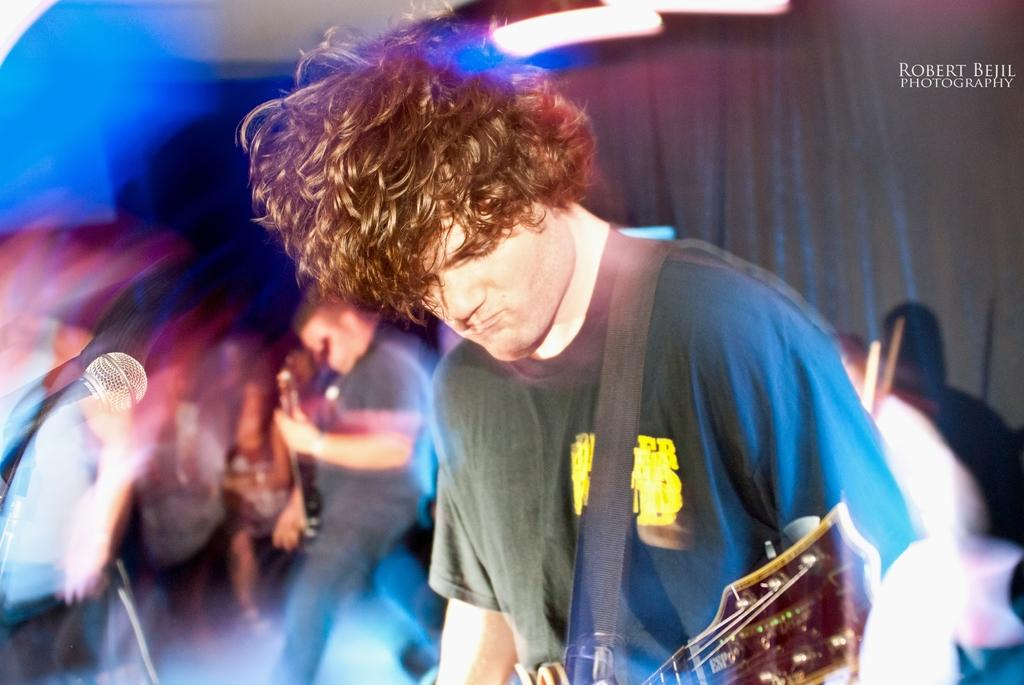What is the main subject of the image? There is a person in the image. What is the person wearing? The person is wearing a black shirt. What object is the person carrying? The person is carrying a guitar. What is in front of the person? There is a microphone in front of the person. Can you describe the people behind the person? There are people behind the person. What type of corn is growing in the image? There is no corn present in the image. What is the relation between the person and the mailbox in the image? There is no mailbox present in the image, so it is not possible to determine any relation between the person and a mailbox. 